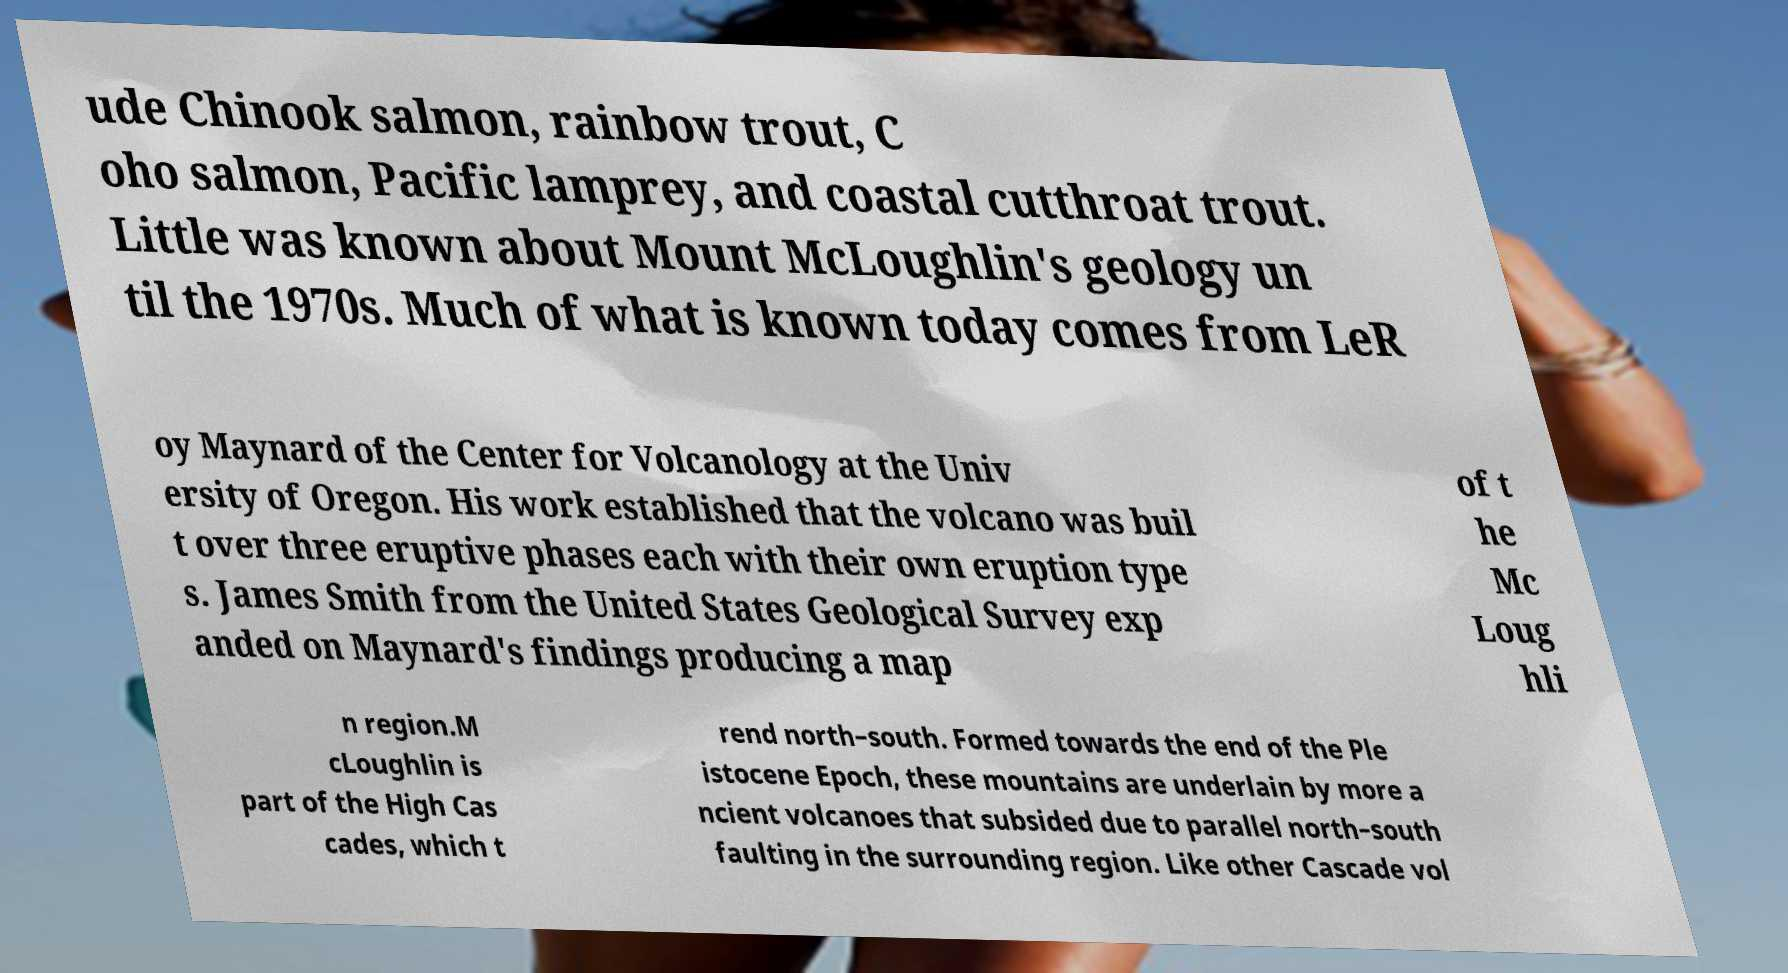Could you extract and type out the text from this image? ude Chinook salmon, rainbow trout, C oho salmon, Pacific lamprey, and coastal cutthroat trout. Little was known about Mount McLoughlin's geology un til the 1970s. Much of what is known today comes from LeR oy Maynard of the Center for Volcanology at the Univ ersity of Oregon. His work established that the volcano was buil t over three eruptive phases each with their own eruption type s. James Smith from the United States Geological Survey exp anded on Maynard's findings producing a map of t he Mc Loug hli n region.M cLoughlin is part of the High Cas cades, which t rend north–south. Formed towards the end of the Ple istocene Epoch, these mountains are underlain by more a ncient volcanoes that subsided due to parallel north–south faulting in the surrounding region. Like other Cascade vol 